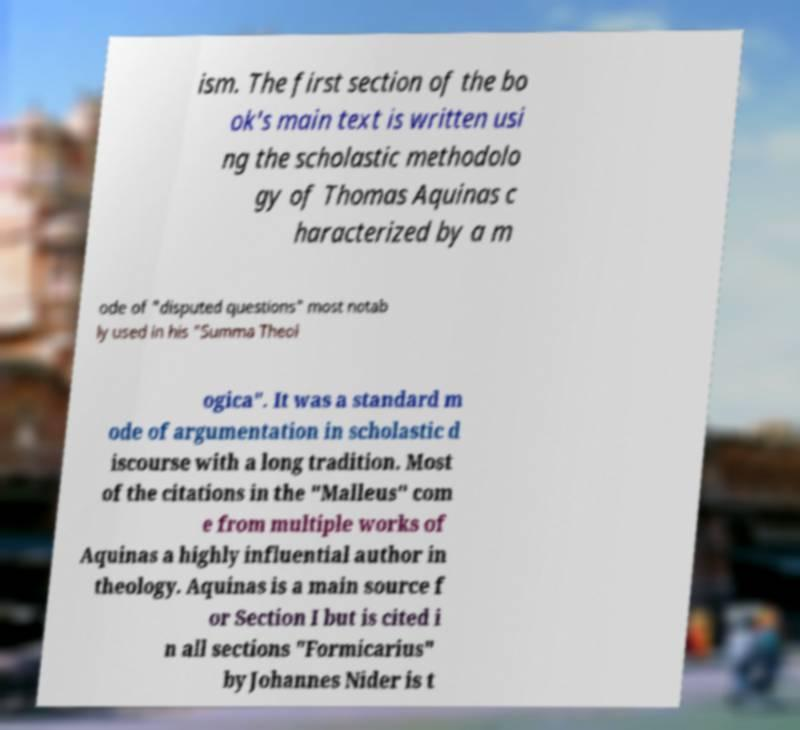For documentation purposes, I need the text within this image transcribed. Could you provide that? ism. The first section of the bo ok's main text is written usi ng the scholastic methodolo gy of Thomas Aquinas c haracterized by a m ode of "disputed questions" most notab ly used in his "Summa Theol ogica". It was a standard m ode of argumentation in scholastic d iscourse with a long tradition. Most of the citations in the "Malleus" com e from multiple works of Aquinas a highly influential author in theology. Aquinas is a main source f or Section I but is cited i n all sections "Formicarius" by Johannes Nider is t 